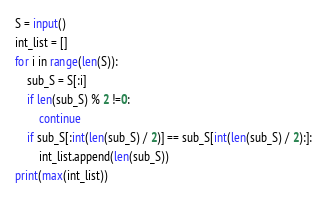Convert code to text. <code><loc_0><loc_0><loc_500><loc_500><_Python_>S = input()
int_list = []
for i in range(len(S)):
    sub_S = S[:i]
    if len(sub_S) % 2 !=0:
        continue
    if sub_S[:int(len(sub_S) / 2)] == sub_S[int(len(sub_S) / 2):]:
        int_list.append(len(sub_S))
print(max(int_list))</code> 